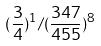<formula> <loc_0><loc_0><loc_500><loc_500>( \frac { 3 } { 4 } ) ^ { 1 } / ( \frac { 3 4 7 } { 4 5 5 } ) ^ { 8 }</formula> 